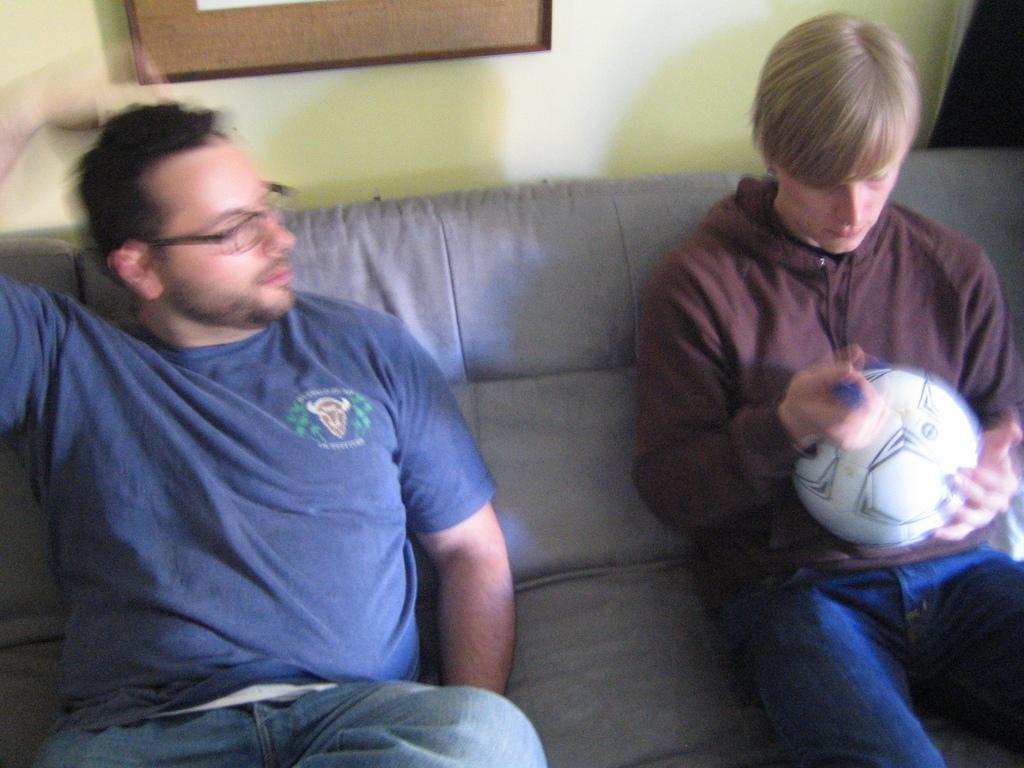Can you describe this image briefly? Two people are present in a picture, one person is at right corner of the picture holding a ball in his hand and in the left corner of the picture one person is wearing blue t-shirt and glasses, behind them there is a wall and some photo on it. 